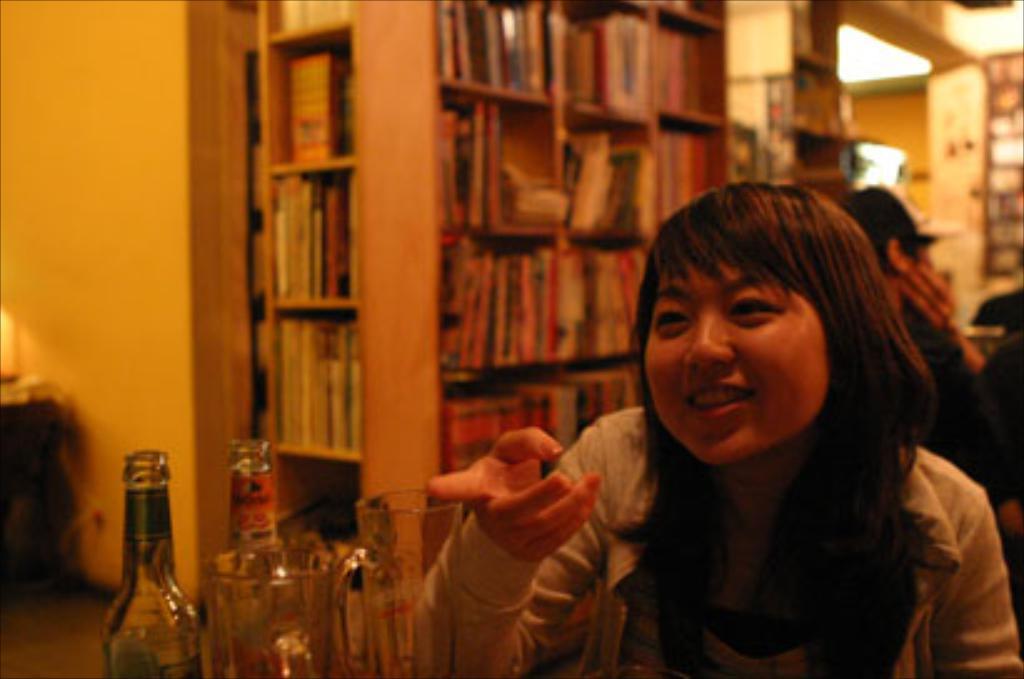Can you describe this image briefly? The image is inside the room. In the image there is a woman sitting on chair in front of a table. On table we can see few bottles, in background there is a shelf with some books and few people sitting on chair. 